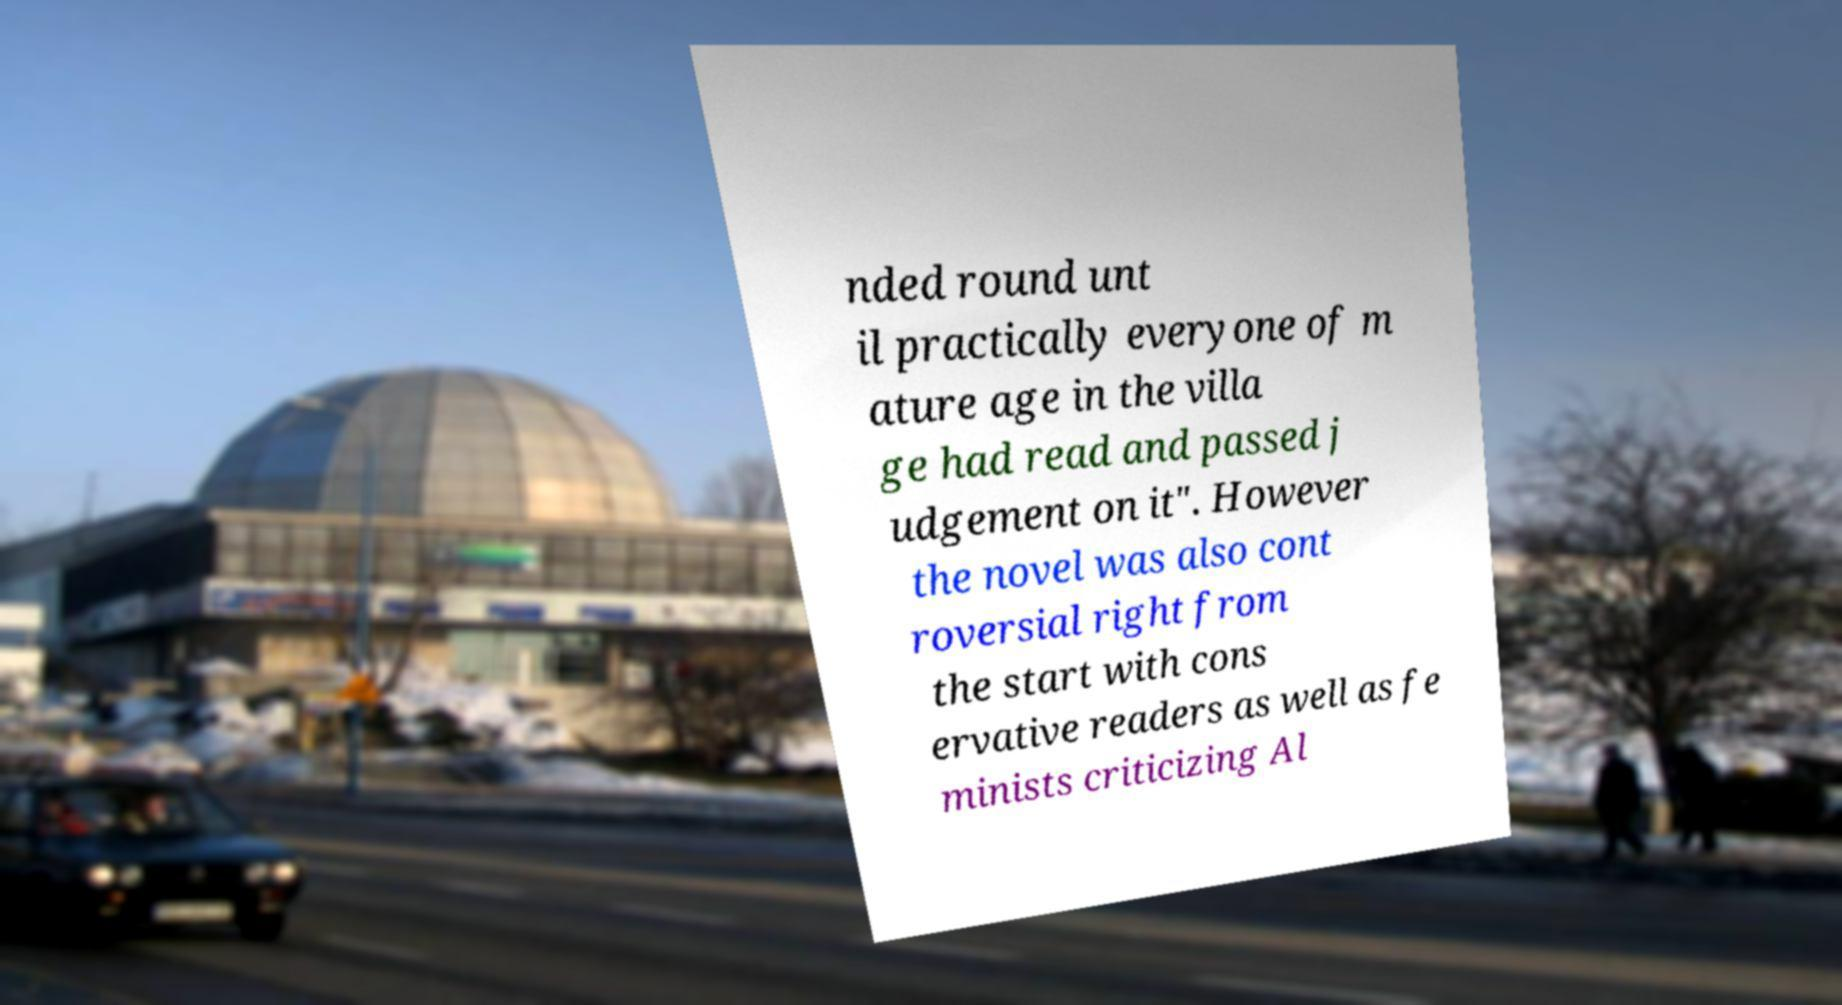Could you assist in decoding the text presented in this image and type it out clearly? nded round unt il practically everyone of m ature age in the villa ge had read and passed j udgement on it". However the novel was also cont roversial right from the start with cons ervative readers as well as fe minists criticizing Al 